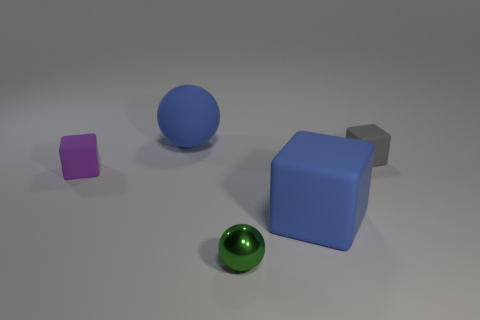Add 4 small red metallic cylinders. How many objects exist? 9 Subtract all purple blocks. How many blocks are left? 2 Subtract all blue spheres. How many spheres are left? 1 Subtract 2 blocks. How many blocks are left? 1 Subtract all brown cubes. Subtract all blue cylinders. How many cubes are left? 3 Subtract all large blue shiny cubes. Subtract all tiny rubber things. How many objects are left? 3 Add 4 blue objects. How many blue objects are left? 6 Add 5 tiny gray things. How many tiny gray things exist? 6 Subtract 0 yellow cubes. How many objects are left? 5 Subtract all balls. How many objects are left? 3 